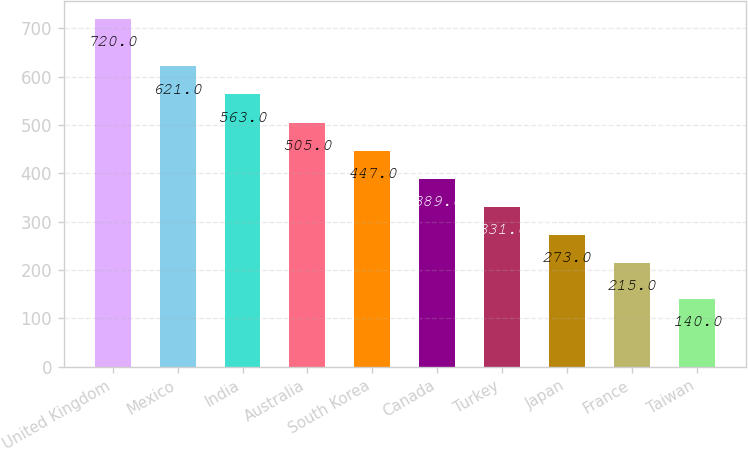Convert chart to OTSL. <chart><loc_0><loc_0><loc_500><loc_500><bar_chart><fcel>United Kingdom<fcel>Mexico<fcel>India<fcel>Australia<fcel>South Korea<fcel>Canada<fcel>Turkey<fcel>Japan<fcel>France<fcel>Taiwan<nl><fcel>720<fcel>621<fcel>563<fcel>505<fcel>447<fcel>389<fcel>331<fcel>273<fcel>215<fcel>140<nl></chart> 